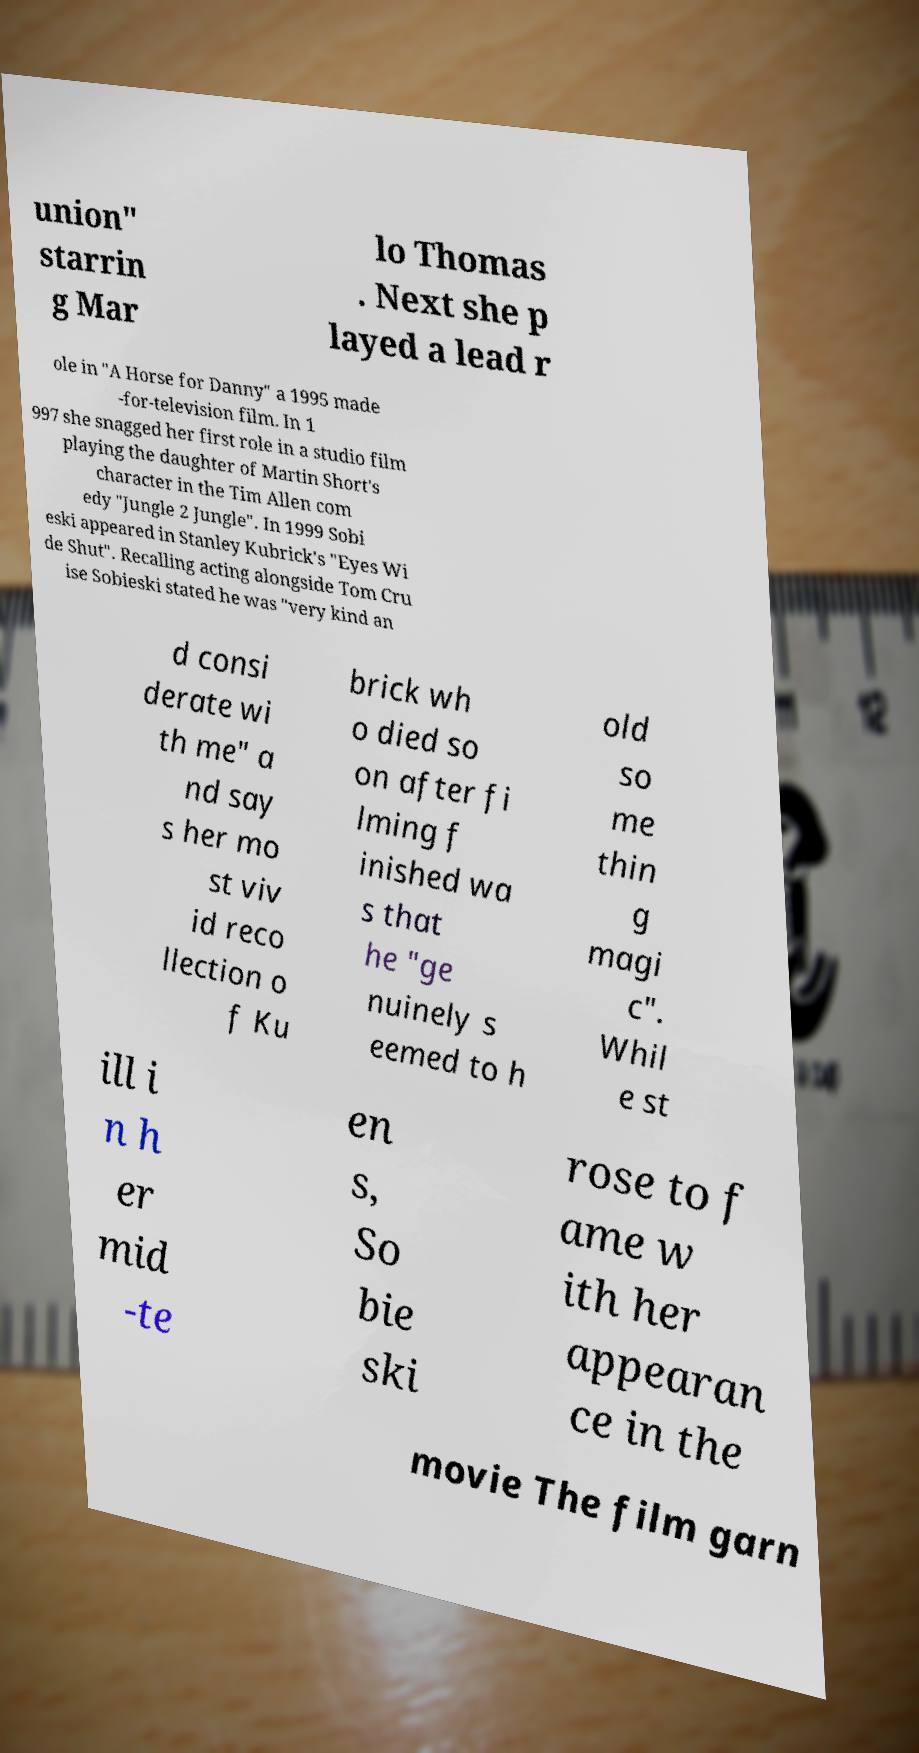I need the written content from this picture converted into text. Can you do that? union" starrin g Mar lo Thomas . Next she p layed a lead r ole in "A Horse for Danny" a 1995 made -for-television film. In 1 997 she snagged her first role in a studio film playing the daughter of Martin Short's character in the Tim Allen com edy "Jungle 2 Jungle". In 1999 Sobi eski appeared in Stanley Kubrick's "Eyes Wi de Shut". Recalling acting alongside Tom Cru ise Sobieski stated he was "very kind an d consi derate wi th me" a nd say s her mo st viv id reco llection o f Ku brick wh o died so on after fi lming f inished wa s that he "ge nuinely s eemed to h old so me thin g magi c". Whil e st ill i n h er mid -te en s, So bie ski rose to f ame w ith her appearan ce in the movie The film garn 